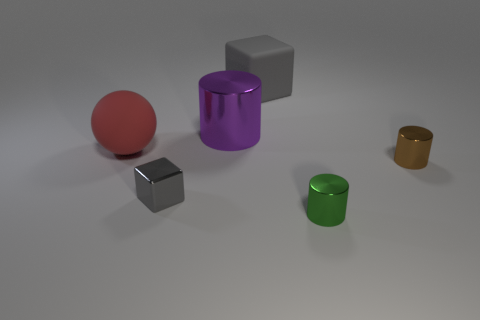Subtract all large cylinders. How many cylinders are left? 2 Add 3 gray matte cubes. How many objects exist? 9 Subtract all green cylinders. How many cylinders are left? 2 Subtract all cubes. How many objects are left? 4 Subtract 1 blocks. How many blocks are left? 1 Subtract all yellow blocks. Subtract all yellow spheres. How many blocks are left? 2 Subtract all balls. Subtract all tiny green metal cylinders. How many objects are left? 4 Add 5 big rubber blocks. How many big rubber blocks are left? 6 Add 5 small cylinders. How many small cylinders exist? 7 Subtract 0 gray balls. How many objects are left? 6 